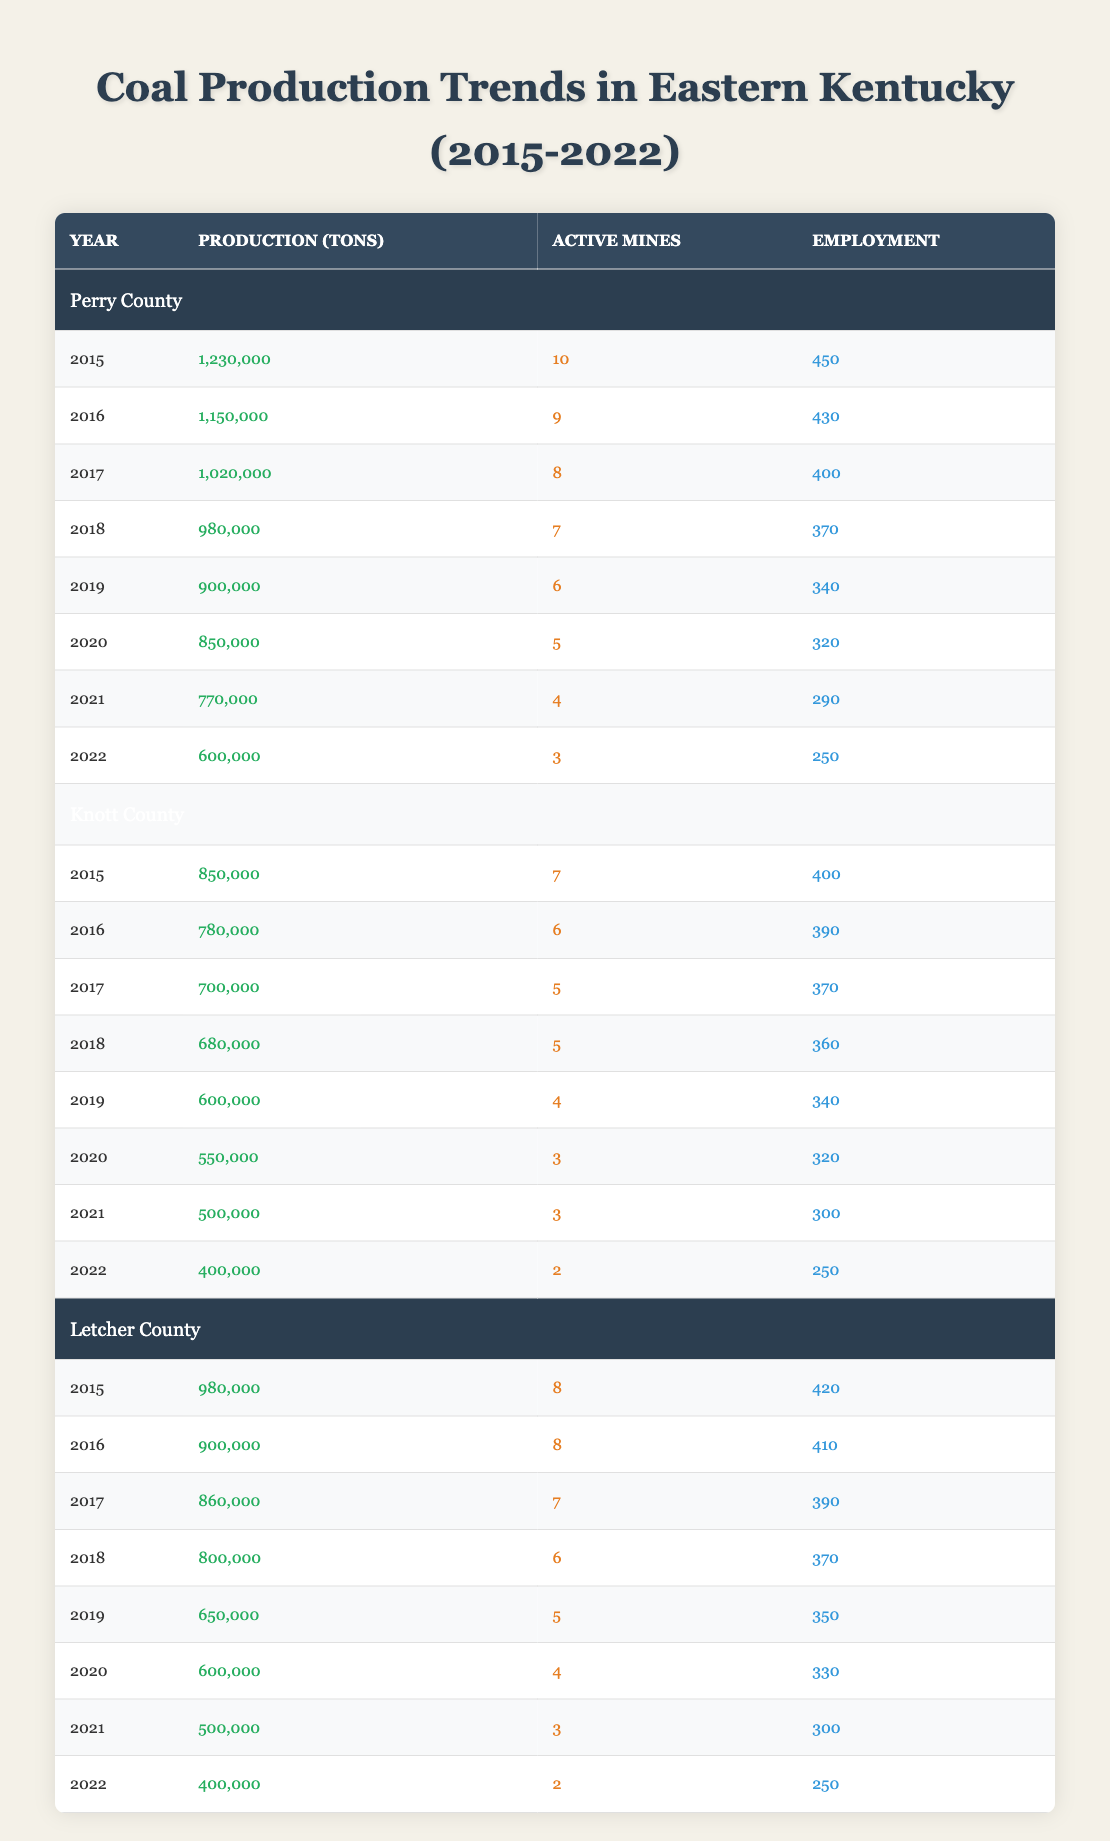What was the total coal production in Perry County from 2015 to 2022? To find the total coal production, we add the production in each year from 2015 to 2022: 1,230,000 + 1,150,000 + 1,020,000 + 980,000 + 900,000 + 850,000 + 770,000 + 600,000 = 6,600,000 tons.
Answer: 6,600,000 tons How many active mines were there in Knott County in 2020? The table shows that in 2020, Knott County had 3 active mines.
Answer: 3 active mines Did employment in Letcher County increase from 2015 to 2022? To determine if employment increased, we compare the employment figures for 2015 (420) and 2022 (250). Since 250 is less than 420, employment decreased.
Answer: No What is the average coal production per mine in Perry County in 2019? In 2019, Perry County produced 900,000 tons of coal with 6 active mines. To find the average, divide the total production by the number of mines: 900,000 / 6 = 150,000 tons per mine.
Answer: 150,000 tons per mine Which county had the highest coal production in 2015? By comparing the production figures for each county in 2015: Perry (1,230,000), Knott (850,000), Letcher (980,000), Perry County had the highest production.
Answer: Perry County What was the decrease in employment in Knott County from 2015 to 2022? The employment in Knott County decreased from 400 in 2015 to 250 in 2022. The decrease can be calculated by subtracting: 400 - 250 = 150.
Answer: 150 In which year did Letcher County have the lowest coal production? By reviewing Letcher County’s production values, the lowest was in 2022 with 400,000 tons.
Answer: 2022 Is it true that the number of active mines decreased in Letcher County between 2015 and 2022? By comparing the number of active mines in 2015 (8) and 2022 (2), it is evident that the number of active mines decreased.
Answer: Yes 